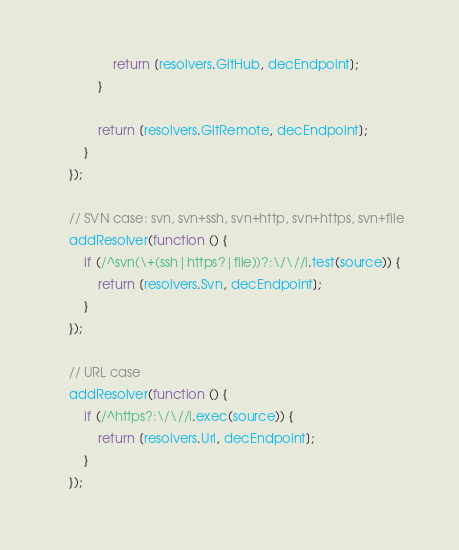<code> <loc_0><loc_0><loc_500><loc_500><_JavaScript_>                return [resolvers.GitHub, decEndpoint];
            }

            return [resolvers.GitRemote, decEndpoint];
        }
    });

    // SVN case: svn, svn+ssh, svn+http, svn+https, svn+file
    addResolver(function () {
        if (/^svn(\+(ssh|https?|file))?:\/\//i.test(source)) {
            return [resolvers.Svn, decEndpoint];
        }
    });

    // URL case
    addResolver(function () {
        if (/^https?:\/\//i.exec(source)) {
            return [resolvers.Url, decEndpoint];
        }
    });

</code> 